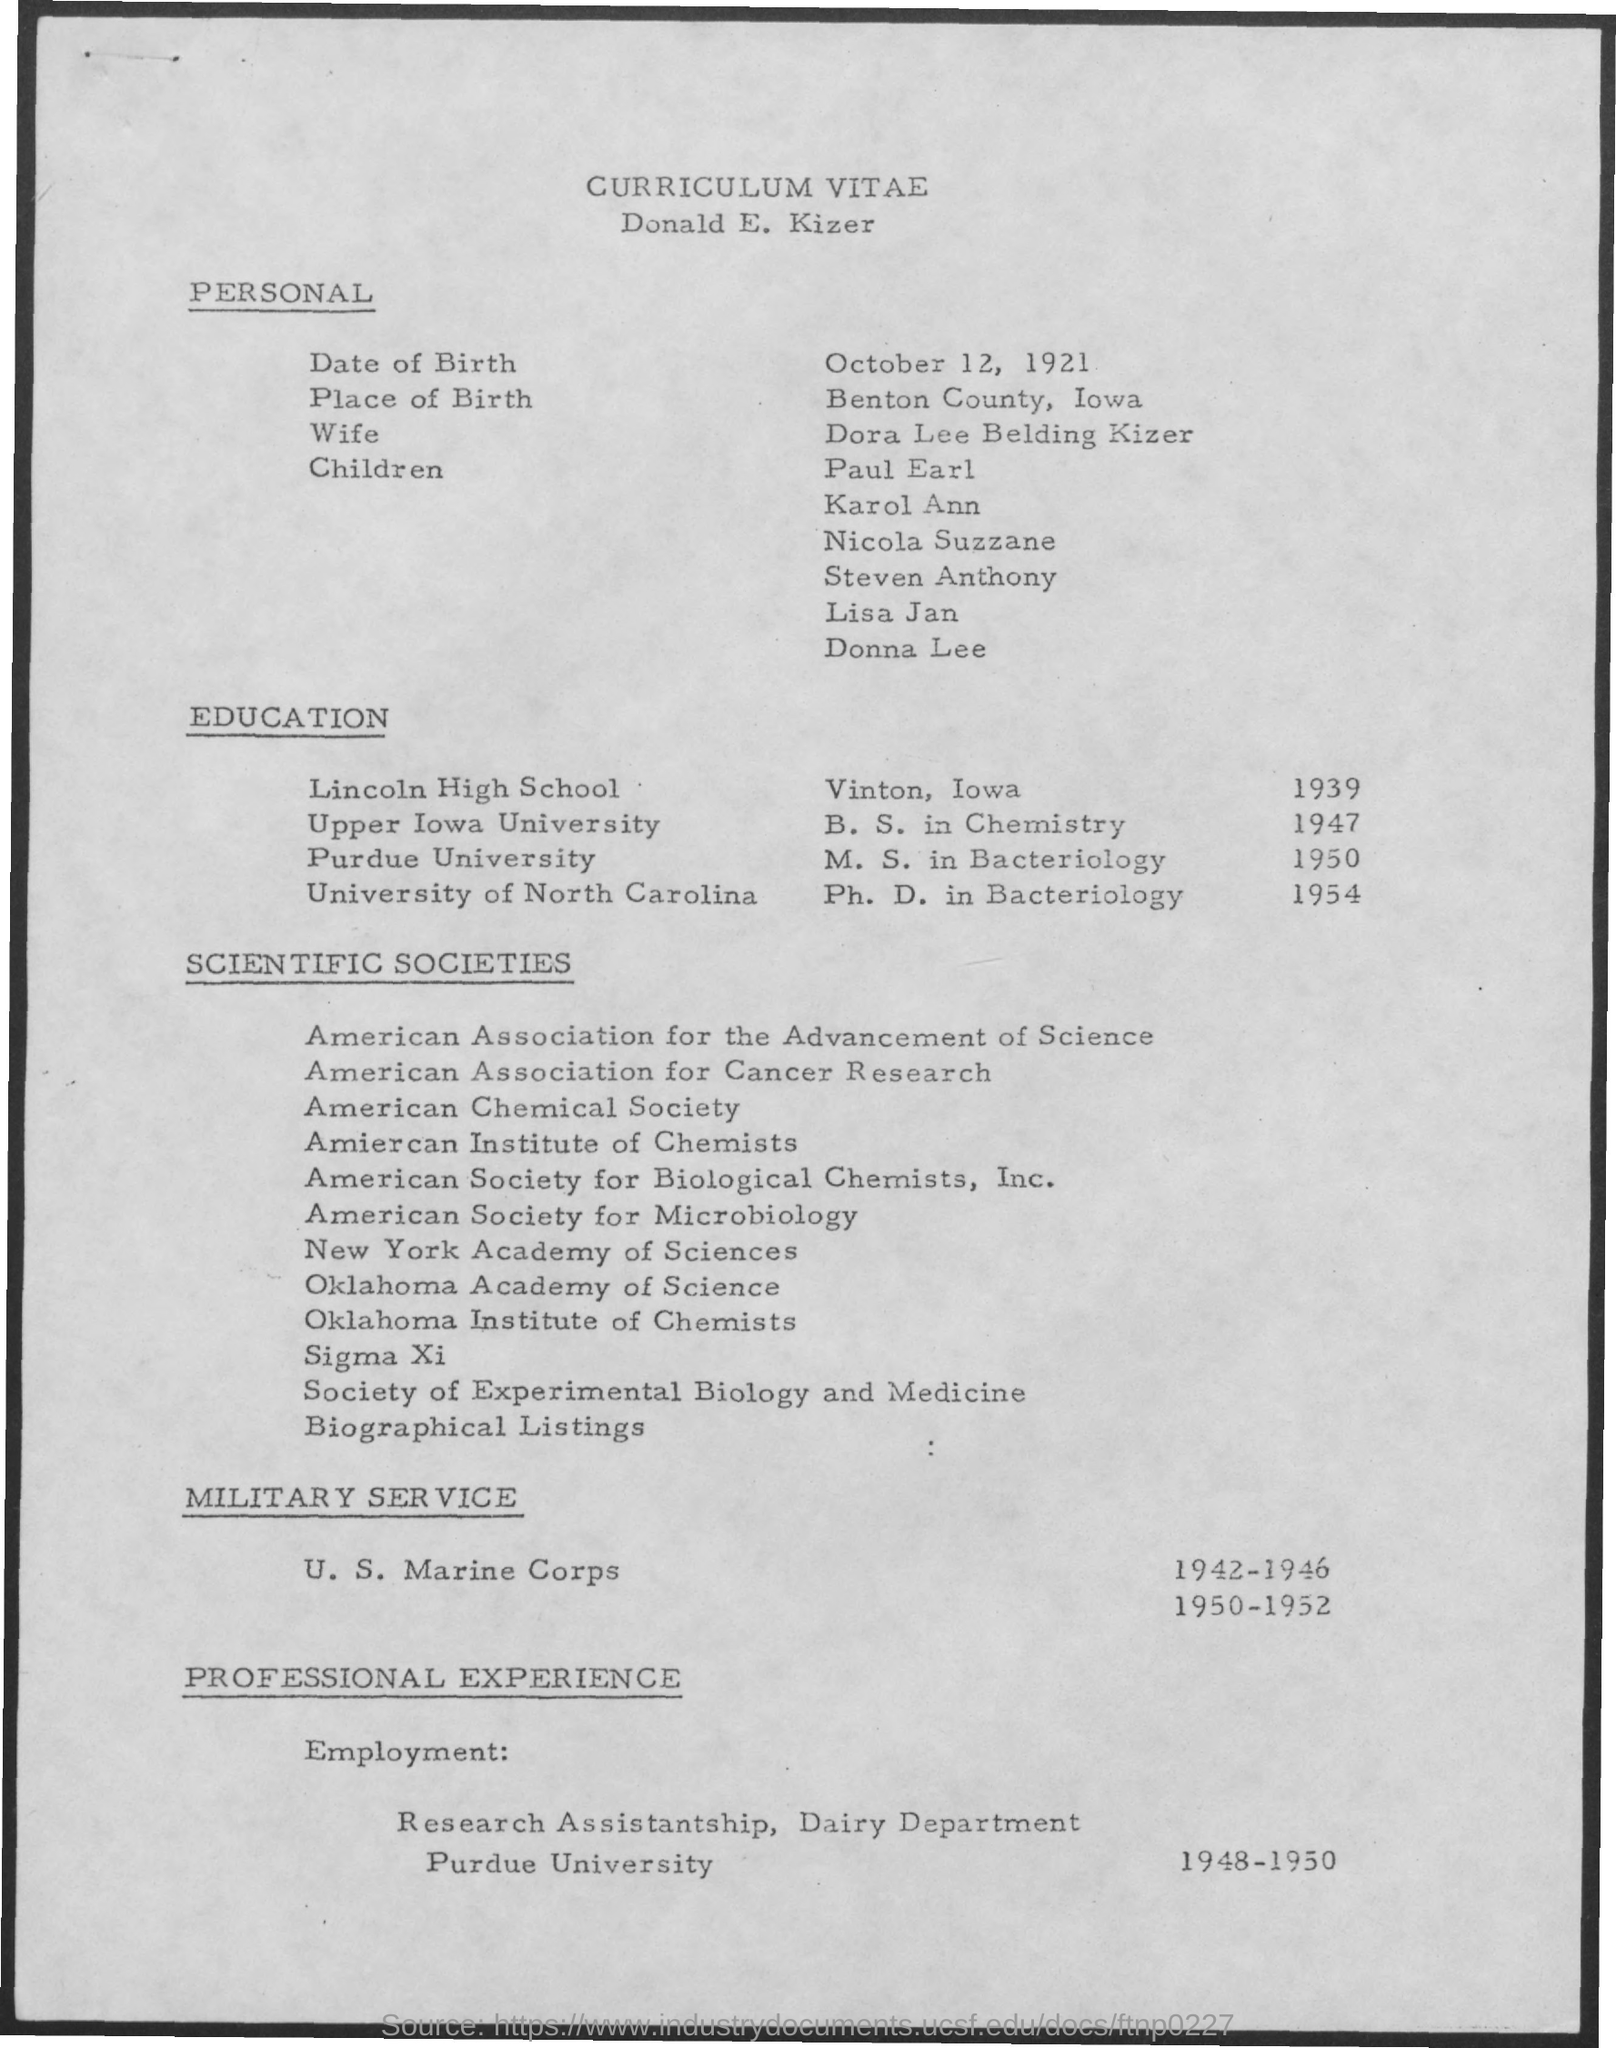Mention a couple of crucial points in this snapshot. In 1947, B.S in chemistry was studied by a person. Mr. Nataraja Rammohan has professional experience in employment from 1948 to 1950. The place of birth is Benton County, Iowa. Ph.D in bacteriology was studied by the person in the year 1954. The person obtained their Ph.D. in Bacteriology from the University of North Carolina. 